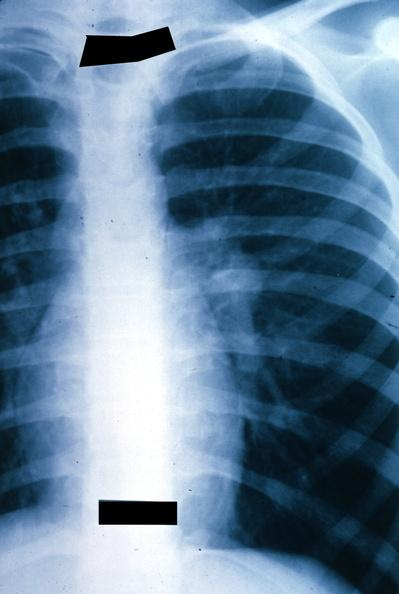what left hilar mass tumor in hilar node?
Answer the question using a single word or phrase. X-ray chest 